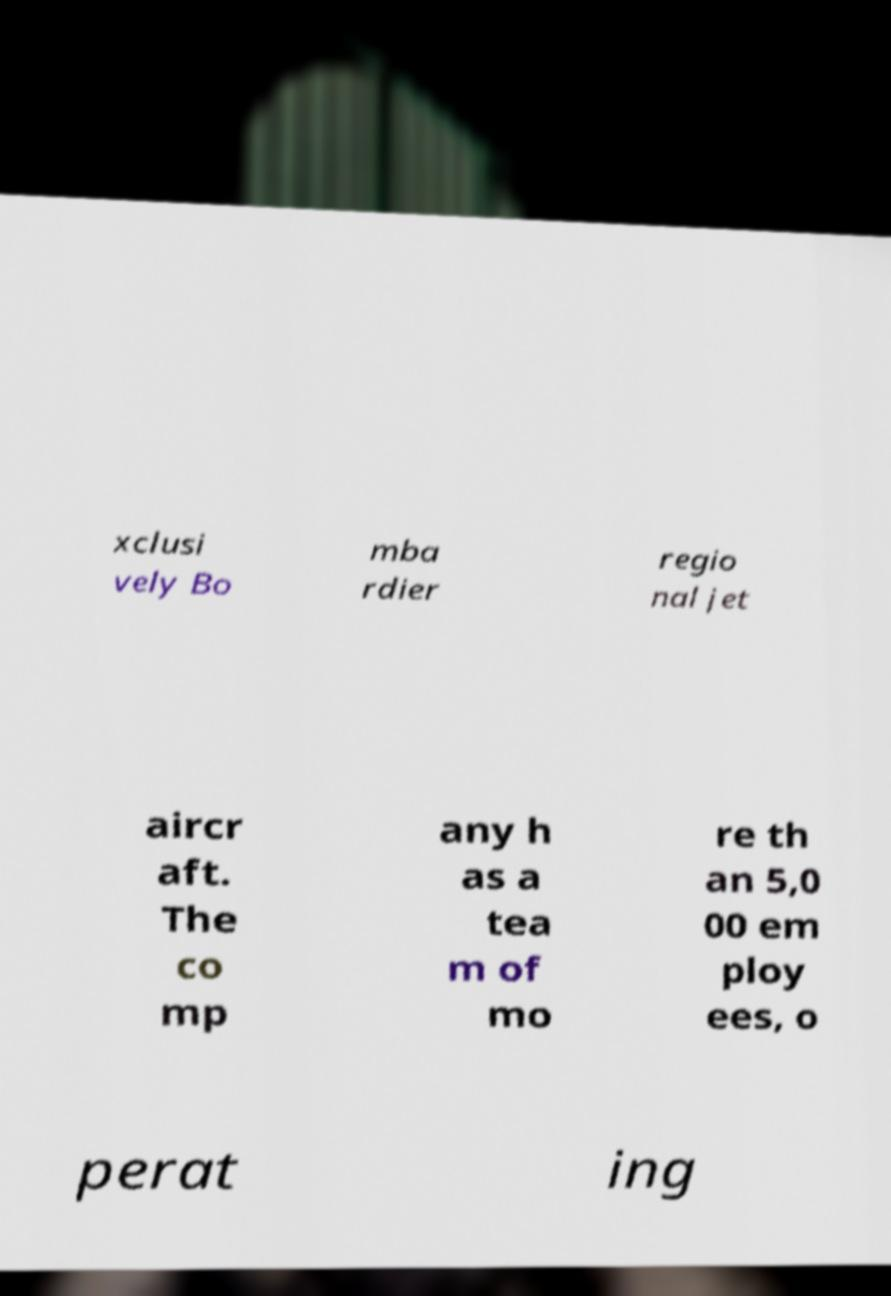What messages or text are displayed in this image? I need them in a readable, typed format. xclusi vely Bo mba rdier regio nal jet aircr aft. The co mp any h as a tea m of mo re th an 5,0 00 em ploy ees, o perat ing 